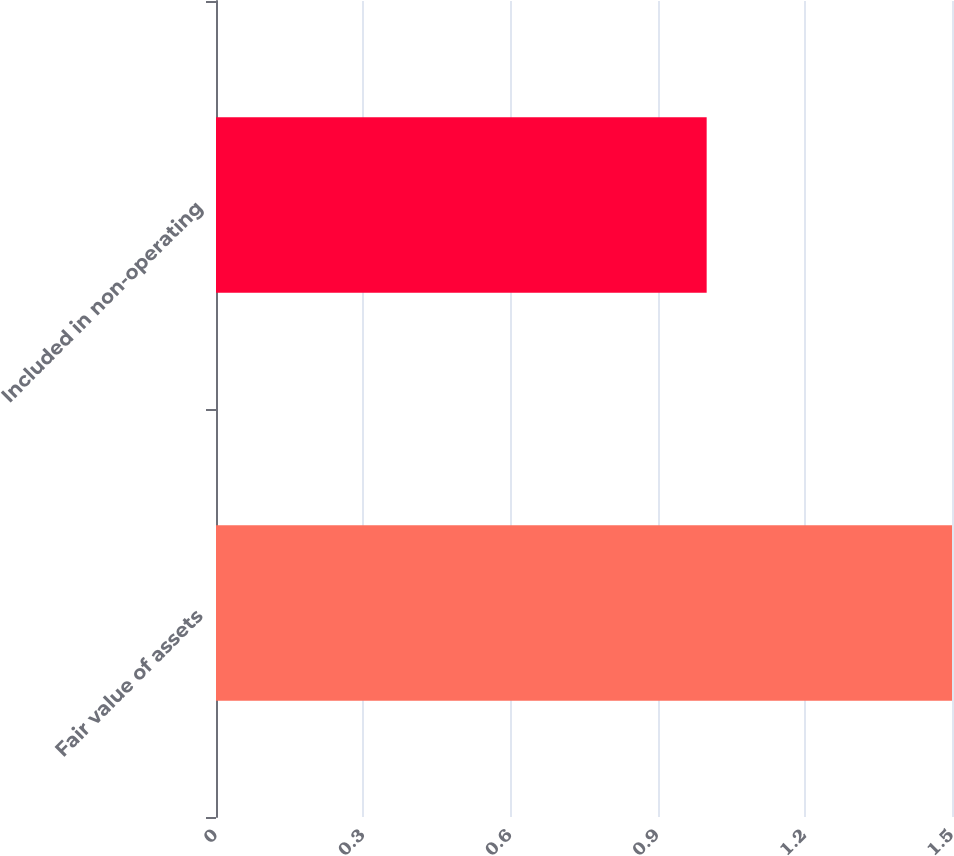<chart> <loc_0><loc_0><loc_500><loc_500><bar_chart><fcel>Fair value of assets<fcel>Included in non-operating<nl><fcel>1.5<fcel>1<nl></chart> 